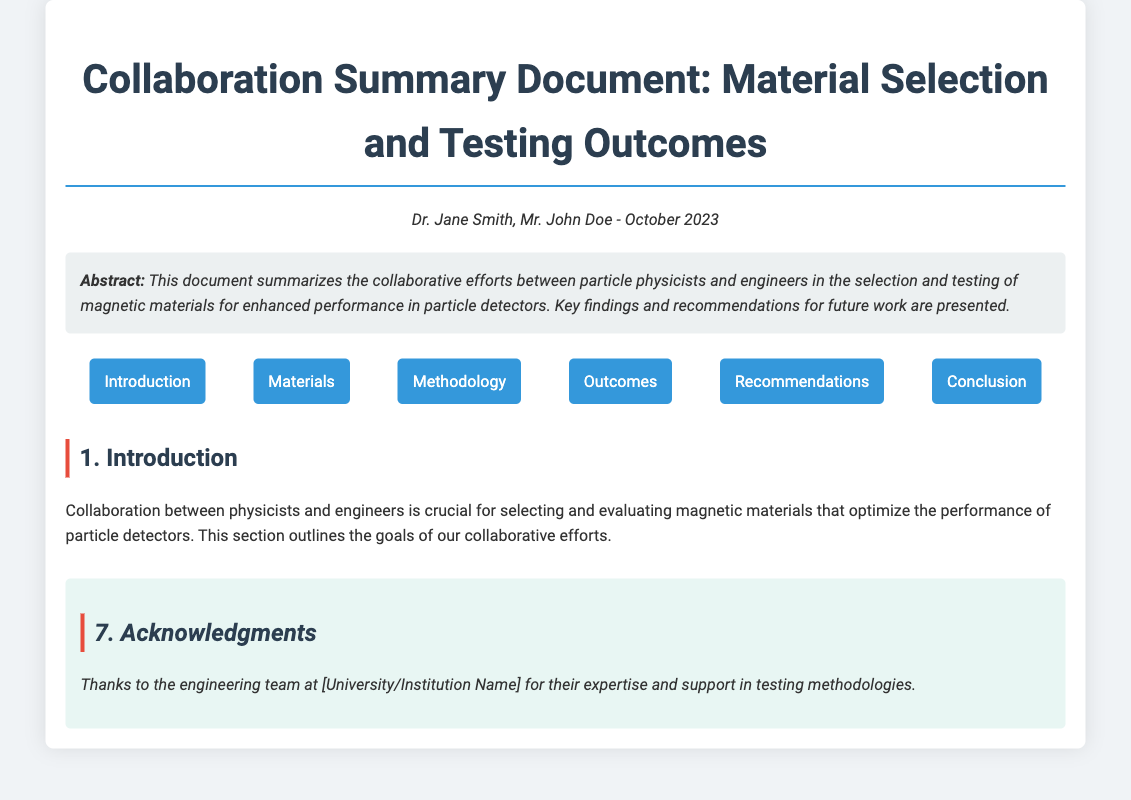What is the title of the document? The title is explicitly stated at the beginning of the document.
Answer: Collaboration Summary Document: Material Selection and Testing Outcomes Who are the authors of the document? The authors are mentioned in the section that lists the authorship.
Answer: Dr. Jane Smith, Mr. John Doe What is the main focus of the collaboration? The abstract provides a summary of the collaboration's focus.
Answer: Magnetic materials for enhanced performance in particle detectors How many types of materials are evaluated? The number is specified in the section detailing the selected materials.
Answer: Three Which material demonstrated superior performance under high-field scenarios? The outcome section highlights the performance of various materials.
Answer: NdFeB What is one recommendation for future studies? Recommendations are listed in the section about future work.
Answer: Long-term stability testing What is the purpose of the collaboration between physicists and engineers? The introduction outlines the goals of the collaborative effort.
Answer: Selection and evaluating magnetic materials What is highlighted as a critical characteristic of the amorphous alloys? The key outcomes section emphasizes important features of each material.
Answer: Reduced noise characteristics What methodology was utilized for testing? The testing methodology section describes the protocols used for material assessment.
Answer: ASTM International standards 